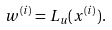Convert formula to latex. <formula><loc_0><loc_0><loc_500><loc_500>w ^ { ( i ) } = L _ { u } ( x ^ { ( i ) } ) .</formula> 